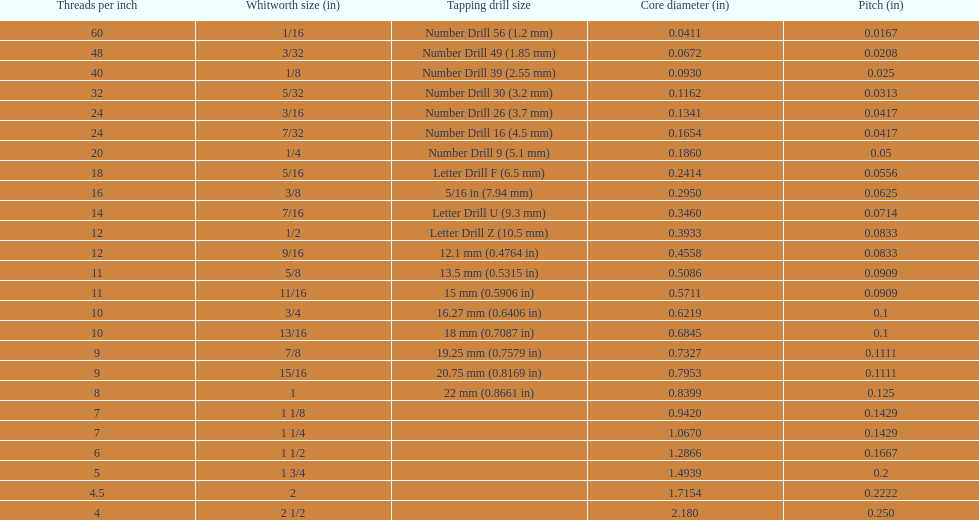What is the total of the first two core diameters? 0.1083. Could you help me parse every detail presented in this table? {'header': ['Threads per\xa0inch', 'Whitworth size (in)', 'Tapping drill size', 'Core diameter (in)', 'Pitch (in)'], 'rows': [['60', '1/16', 'Number Drill 56 (1.2\xa0mm)', '0.0411', '0.0167'], ['48', '3/32', 'Number Drill 49 (1.85\xa0mm)', '0.0672', '0.0208'], ['40', '1/8', 'Number Drill 39 (2.55\xa0mm)', '0.0930', '0.025'], ['32', '5/32', 'Number Drill 30 (3.2\xa0mm)', '0.1162', '0.0313'], ['24', '3/16', 'Number Drill 26 (3.7\xa0mm)', '0.1341', '0.0417'], ['24', '7/32', 'Number Drill 16 (4.5\xa0mm)', '0.1654', '0.0417'], ['20', '1/4', 'Number Drill 9 (5.1\xa0mm)', '0.1860', '0.05'], ['18', '5/16', 'Letter Drill F (6.5\xa0mm)', '0.2414', '0.0556'], ['16', '3/8', '5/16\xa0in (7.94\xa0mm)', '0.2950', '0.0625'], ['14', '7/16', 'Letter Drill U (9.3\xa0mm)', '0.3460', '0.0714'], ['12', '1/2', 'Letter Drill Z (10.5\xa0mm)', '0.3933', '0.0833'], ['12', '9/16', '12.1\xa0mm (0.4764\xa0in)', '0.4558', '0.0833'], ['11', '5/8', '13.5\xa0mm (0.5315\xa0in)', '0.5086', '0.0909'], ['11', '11/16', '15\xa0mm (0.5906\xa0in)', '0.5711', '0.0909'], ['10', '3/4', '16.27\xa0mm (0.6406\xa0in)', '0.6219', '0.1'], ['10', '13/16', '18\xa0mm (0.7087\xa0in)', '0.6845', '0.1'], ['9', '7/8', '19.25\xa0mm (0.7579\xa0in)', '0.7327', '0.1111'], ['9', '15/16', '20.75\xa0mm (0.8169\xa0in)', '0.7953', '0.1111'], ['8', '1', '22\xa0mm (0.8661\xa0in)', '0.8399', '0.125'], ['7', '1 1/8', '', '0.9420', '0.1429'], ['7', '1 1/4', '', '1.0670', '0.1429'], ['6', '1 1/2', '', '1.2866', '0.1667'], ['5', '1 3/4', '', '1.4939', '0.2'], ['4.5', '2', '', '1.7154', '0.2222'], ['4', '2 1/2', '', '2.180', '0.250']]} 